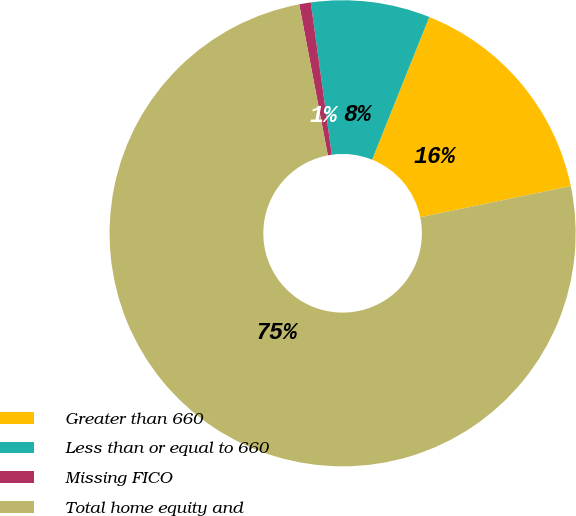Convert chart to OTSL. <chart><loc_0><loc_0><loc_500><loc_500><pie_chart><fcel>Greater than 660<fcel>Less than or equal to 660<fcel>Missing FICO<fcel>Total home equity and<nl><fcel>15.69%<fcel>8.25%<fcel>0.8%<fcel>75.26%<nl></chart> 